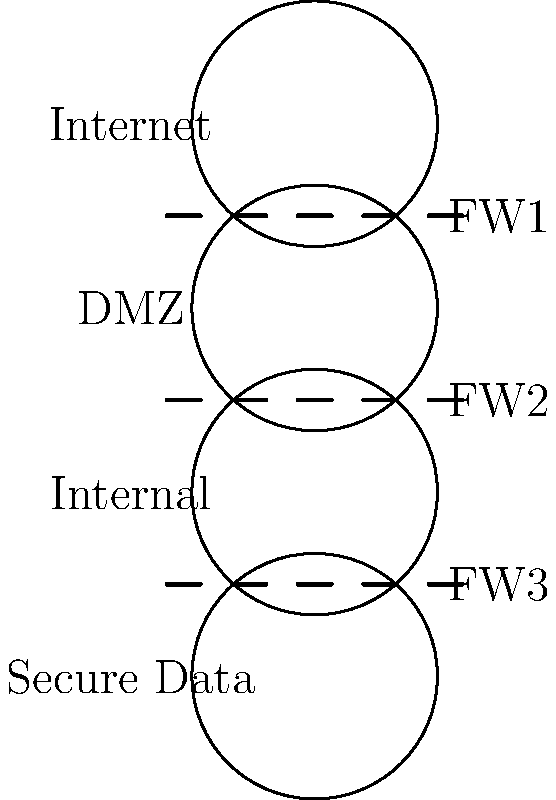In the secure network design shown above, which critical component ensures the isolation and protection of sensitive team strategy data from potential external threats? To understand the secure network design for protecting sensitive team strategy data, let's analyze the diagram step-by-step:

1. The network is divided into four distinct layers:
   a) Internet (top layer)
   b) DMZ (Demilitarized Zone)
   c) Internal network
   d) Secure Data (bottom layer)

2. Between each layer, there is a firewall:
   - FW1 between Internet and DMZ
   - FW2 between DMZ and Internal network
   - FW3 between Internal network and Secure Data

3. The sensitive team strategy data is located in the bottommost layer, labeled "Secure Data."

4. To reach the Secure Data layer from the Internet, an attacker would need to bypass three firewalls (FW1, FW2, and FW3).

5. Each firewall acts as a barrier, filtering and controlling traffic between the layers.

6. The most critical component for protecting the sensitive team strategy data is the final firewall, FW3.

7. FW3 is the last line of defense that directly controls access to the Secure Data layer, ensuring that only authorized traffic from the Internal network can reach the sensitive information.

Therefore, while all firewalls contribute to the overall security, Firewall 3 (FW3) is the critical component that ensures the isolation and protection of sensitive team strategy data from potential external threats.
Answer: Firewall 3 (FW3) 